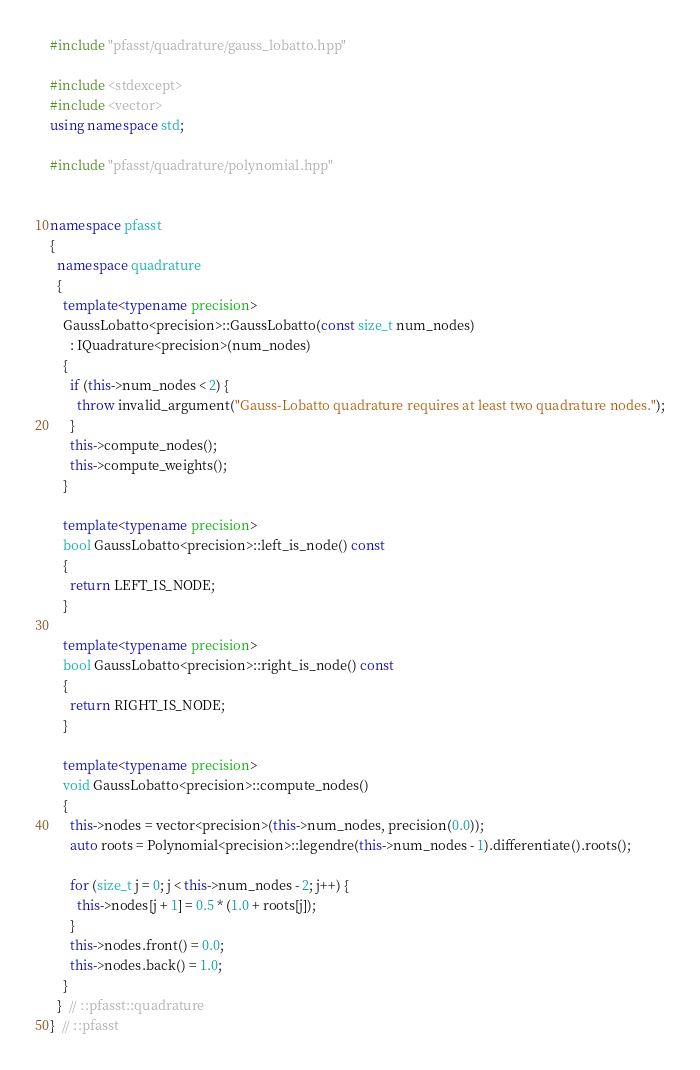<code> <loc_0><loc_0><loc_500><loc_500><_C++_>#include "pfasst/quadrature/gauss_lobatto.hpp"

#include <stdexcept>
#include <vector>
using namespace std;

#include "pfasst/quadrature/polynomial.hpp"


namespace pfasst
{
  namespace quadrature
  {
    template<typename precision>
    GaussLobatto<precision>::GaussLobatto(const size_t num_nodes)
      : IQuadrature<precision>(num_nodes)
    {
      if (this->num_nodes < 2) {
        throw invalid_argument("Gauss-Lobatto quadrature requires at least two quadrature nodes.");
      }
      this->compute_nodes();
      this->compute_weights();
    }

    template<typename precision>
    bool GaussLobatto<precision>::left_is_node() const
    {
      return LEFT_IS_NODE;
    }

    template<typename precision>
    bool GaussLobatto<precision>::right_is_node() const
    {
      return RIGHT_IS_NODE;
    }

    template<typename precision>
    void GaussLobatto<precision>::compute_nodes()
    {
      this->nodes = vector<precision>(this->num_nodes, precision(0.0));
      auto roots = Polynomial<precision>::legendre(this->num_nodes - 1).differentiate().roots();

      for (size_t j = 0; j < this->num_nodes - 2; j++) {
        this->nodes[j + 1] = 0.5 * (1.0 + roots[j]);
      }
      this->nodes.front() = 0.0;
      this->nodes.back() = 1.0;
    }
  }  // ::pfasst::quadrature
}  // ::pfasst
</code> 